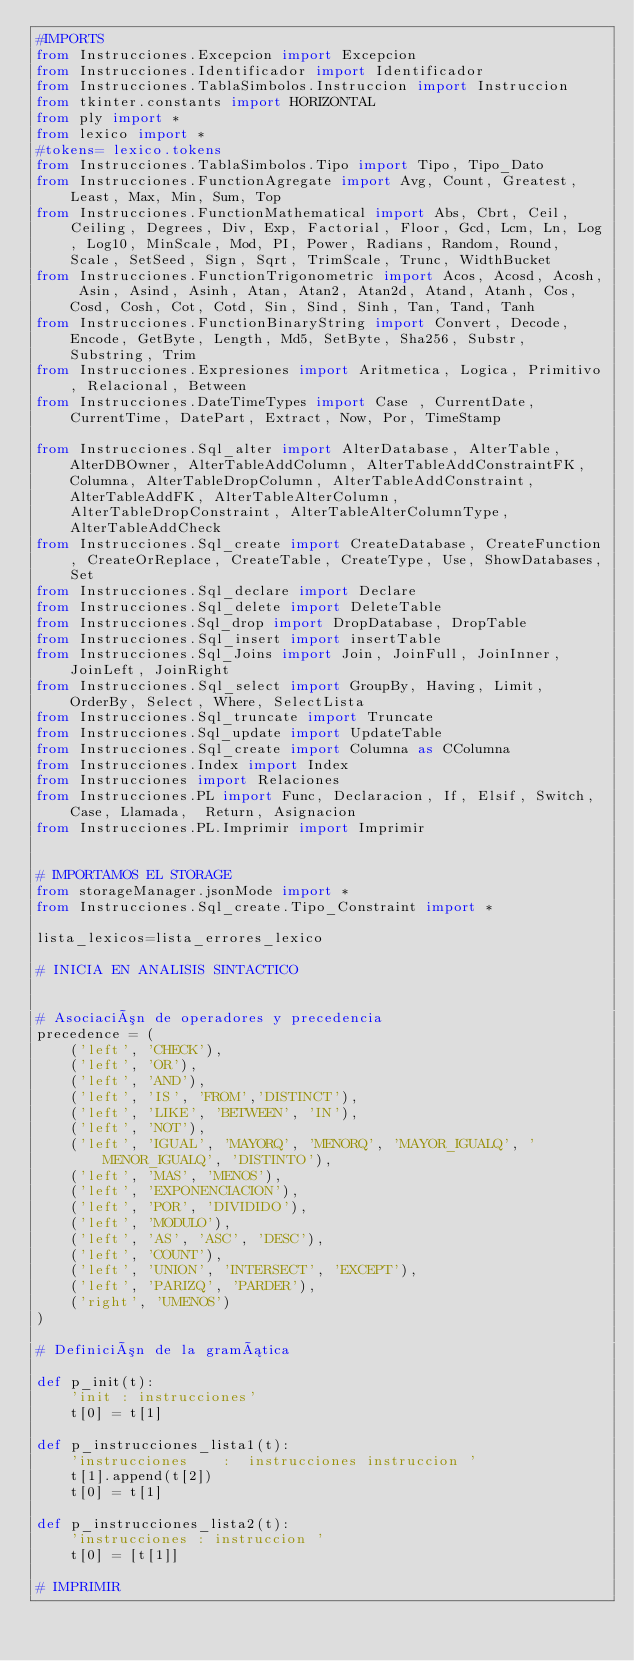Convert code to text. <code><loc_0><loc_0><loc_500><loc_500><_Python_>#IMPORTS
from Instrucciones.Excepcion import Excepcion
from Instrucciones.Identificador import Identificador
from Instrucciones.TablaSimbolos.Instruccion import Instruccion
from tkinter.constants import HORIZONTAL
from ply import *
from lexico import *
#tokens= lexico.tokens
from Instrucciones.TablaSimbolos.Tipo import Tipo, Tipo_Dato
from Instrucciones.FunctionAgregate import Avg, Count, Greatest, Least, Max, Min, Sum, Top
from Instrucciones.FunctionMathematical import Abs, Cbrt, Ceil, Ceiling, Degrees, Div, Exp, Factorial, Floor, Gcd, Lcm, Ln, Log, Log10, MinScale, Mod, PI, Power, Radians, Random, Round, Scale, SetSeed, Sign, Sqrt, TrimScale, Trunc, WidthBucket
from Instrucciones.FunctionTrigonometric import Acos, Acosd, Acosh, Asin, Asind, Asinh, Atan, Atan2, Atan2d, Atand, Atanh, Cos, Cosd, Cosh, Cot, Cotd, Sin, Sind, Sinh, Tan, Tand, Tanh
from Instrucciones.FunctionBinaryString import Convert, Decode, Encode, GetByte, Length, Md5, SetByte, Sha256, Substr, Substring, Trim
from Instrucciones.Expresiones import Aritmetica, Logica, Primitivo, Relacional, Between
from Instrucciones.DateTimeTypes import Case , CurrentDate, CurrentTime, DatePart, Extract, Now, Por, TimeStamp

from Instrucciones.Sql_alter import AlterDatabase, AlterTable, AlterDBOwner, AlterTableAddColumn, AlterTableAddConstraintFK, Columna, AlterTableDropColumn, AlterTableAddConstraint, AlterTableAddFK, AlterTableAlterColumn, AlterTableDropConstraint, AlterTableAlterColumnType, AlterTableAddCheck
from Instrucciones.Sql_create import CreateDatabase, CreateFunction, CreateOrReplace, CreateTable, CreateType, Use, ShowDatabases,Set
from Instrucciones.Sql_declare import Declare
from Instrucciones.Sql_delete import DeleteTable
from Instrucciones.Sql_drop import DropDatabase, DropTable
from Instrucciones.Sql_insert import insertTable
from Instrucciones.Sql_Joins import Join, JoinFull, JoinInner, JoinLeft, JoinRight
from Instrucciones.Sql_select import GroupBy, Having, Limit, OrderBy, Select, Where, SelectLista
from Instrucciones.Sql_truncate import Truncate
from Instrucciones.Sql_update import UpdateTable
from Instrucciones.Sql_create import Columna as CColumna
from Instrucciones.Index import Index
from Instrucciones import Relaciones
from Instrucciones.PL import Func, Declaracion, If, Elsif, Switch, Case, Llamada,  Return, Asignacion
from Instrucciones.PL.Imprimir import Imprimir


# IMPORTAMOS EL STORAGE
from storageManager.jsonMode import *
from Instrucciones.Sql_create.Tipo_Constraint import *

lista_lexicos=lista_errores_lexico

# INICIA EN ANALISIS SINTACTICO


# Asociación de operadores y precedencia
precedence = (
    ('left', 'CHECK'),
    ('left', 'OR'),
    ('left', 'AND'),
    ('left', 'IS', 'FROM','DISTINCT'),
    ('left', 'LIKE', 'BETWEEN', 'IN'),
    ('left', 'NOT'),
    ('left', 'IGUAL', 'MAYORQ', 'MENORQ', 'MAYOR_IGUALQ', 'MENOR_IGUALQ', 'DISTINTO'),
    ('left', 'MAS', 'MENOS'),
    ('left', 'EXPONENCIACION'),
    ('left', 'POR', 'DIVIDIDO'),
    ('left', 'MODULO'),
    ('left', 'AS', 'ASC', 'DESC'),
    ('left', 'COUNT'),
    ('left', 'UNION', 'INTERSECT', 'EXCEPT'),
    ('left', 'PARIZQ', 'PARDER'),
    ('right', 'UMENOS')
)

# Definición de la gramática

def p_init(t):
    'init : instrucciones'
    t[0] = t[1]

def p_instrucciones_lista1(t):
    'instrucciones    :  instrucciones instruccion '
    t[1].append(t[2])
    t[0] = t[1]
    
def p_instrucciones_lista2(t):
    'instrucciones : instruccion '
    t[0] = [t[1]]

# IMPRIMIR</code> 